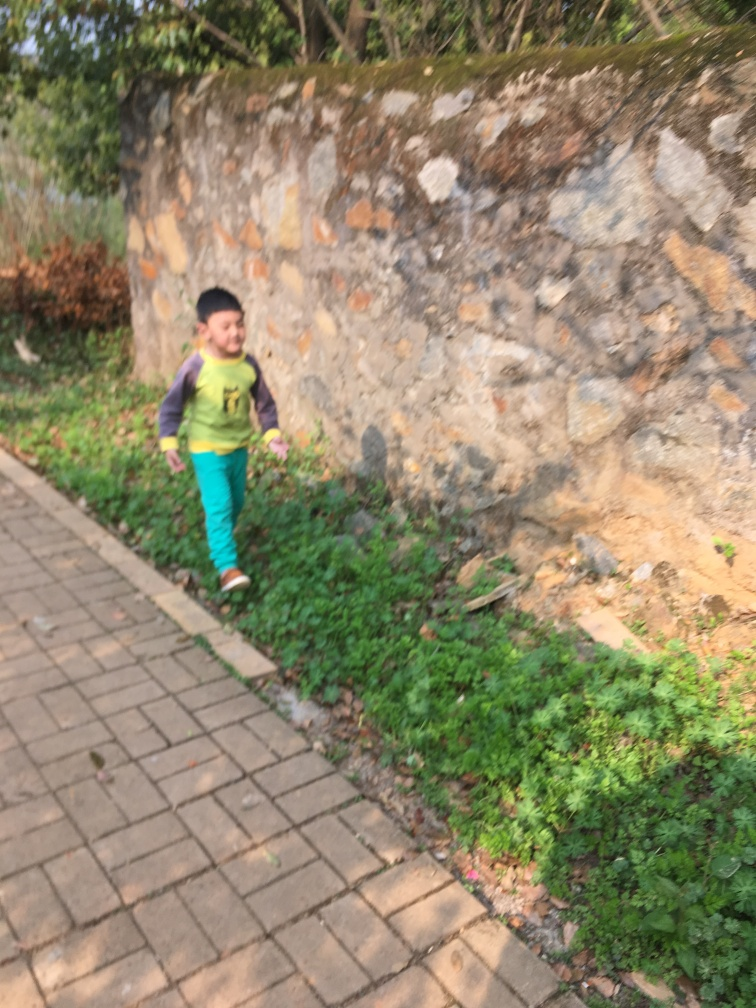What could be the reason for the blurriness in the image? The blurriness is likely due to motion blur, a common occurrence when photographing moving subjects at a slow shutter speed. The subject's quick movement combined with a delay in the camera's shutter response can result in such an effect. How could the motion blur have been prevented? To prevent motion blur, the photographer could have used a faster shutter speed to freeze the action of the moving subject. Increasing the camera's ISO sensitivity or using a wider aperture to allow more light to hit the sensor would also enable a quicker shutter speed. 